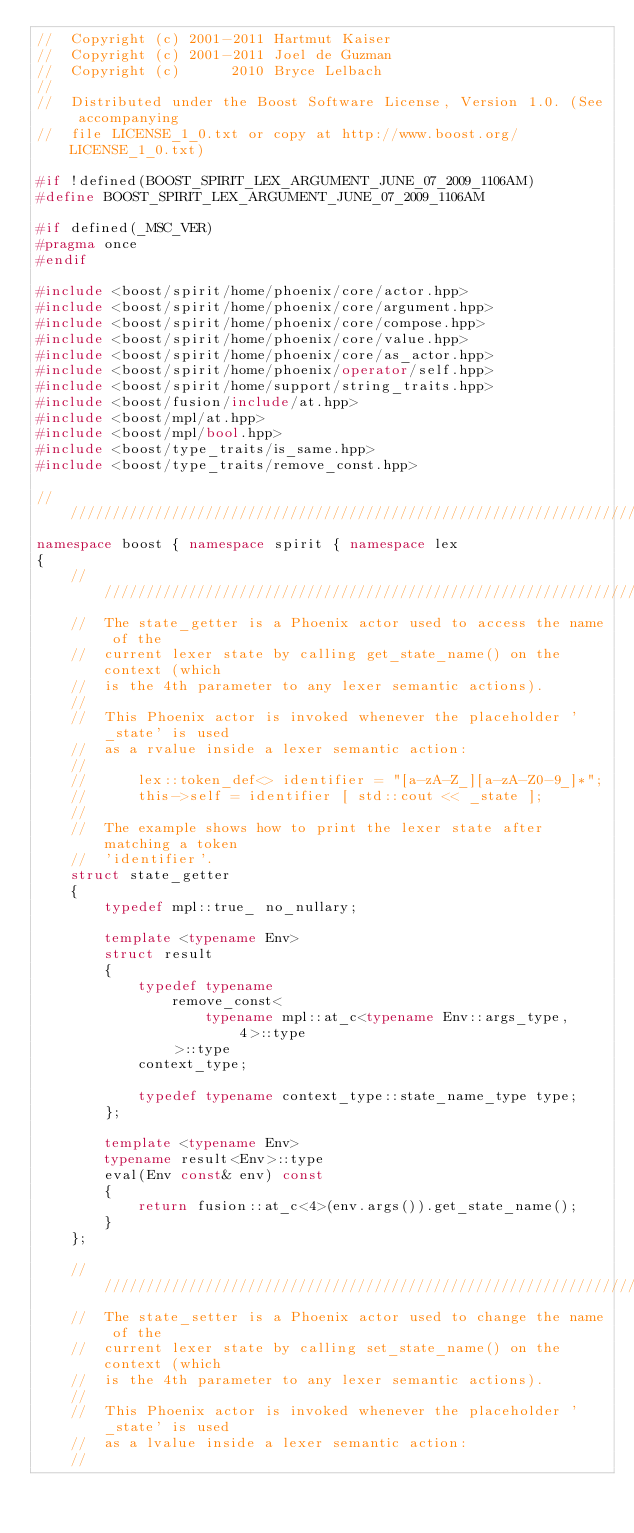<code> <loc_0><loc_0><loc_500><loc_500><_C++_>//  Copyright (c) 2001-2011 Hartmut Kaiser
//  Copyright (c) 2001-2011 Joel de Guzman
//  Copyright (c)      2010 Bryce Lelbach
// 
//  Distributed under the Boost Software License, Version 1.0. (See accompanying 
//  file LICENSE_1_0.txt or copy at http://www.boost.org/LICENSE_1_0.txt)

#if !defined(BOOST_SPIRIT_LEX_ARGUMENT_JUNE_07_2009_1106AM)
#define BOOST_SPIRIT_LEX_ARGUMENT_JUNE_07_2009_1106AM

#if defined(_MSC_VER)
#pragma once
#endif

#include <boost/spirit/home/phoenix/core/actor.hpp>
#include <boost/spirit/home/phoenix/core/argument.hpp>
#include <boost/spirit/home/phoenix/core/compose.hpp>
#include <boost/spirit/home/phoenix/core/value.hpp>
#include <boost/spirit/home/phoenix/core/as_actor.hpp>
#include <boost/spirit/home/phoenix/operator/self.hpp>
#include <boost/spirit/home/support/string_traits.hpp>
#include <boost/fusion/include/at.hpp>
#include <boost/mpl/at.hpp>
#include <boost/mpl/bool.hpp>
#include <boost/type_traits/is_same.hpp>
#include <boost/type_traits/remove_const.hpp>

///////////////////////////////////////////////////////////////////////////////
namespace boost { namespace spirit { namespace lex
{
    ///////////////////////////////////////////////////////////////////////////
    //  The state_getter is a Phoenix actor used to access the name of the 
    //  current lexer state by calling get_state_name() on the context (which 
    //  is the 4th parameter to any lexer semantic actions).
    //
    //  This Phoenix actor is invoked whenever the placeholder '_state' is used
    //  as a rvalue inside a lexer semantic action:
    //
    //      lex::token_def<> identifier = "[a-zA-Z_][a-zA-Z0-9_]*";
    //      this->self = identifier [ std::cout << _state ];
    //
    //  The example shows how to print the lexer state after matching a token
    //  'identifier'.
    struct state_getter
    {
        typedef mpl::true_ no_nullary;

        template <typename Env>
        struct result
        {
            typedef typename
                remove_const<
                    typename mpl::at_c<typename Env::args_type, 4>::type
                >::type
            context_type;

            typedef typename context_type::state_name_type type;
        };

        template <typename Env>
        typename result<Env>::type
        eval(Env const& env) const
        {
            return fusion::at_c<4>(env.args()).get_state_name();
        }
    };

    ///////////////////////////////////////////////////////////////////////////
    //  The state_setter is a Phoenix actor used to change the name of the 
    //  current lexer state by calling set_state_name() on the context (which 
    //  is the 4th parameter to any lexer semantic actions).
    //
    //  This Phoenix actor is invoked whenever the placeholder '_state' is used
    //  as a lvalue inside a lexer semantic action:
    //</code> 